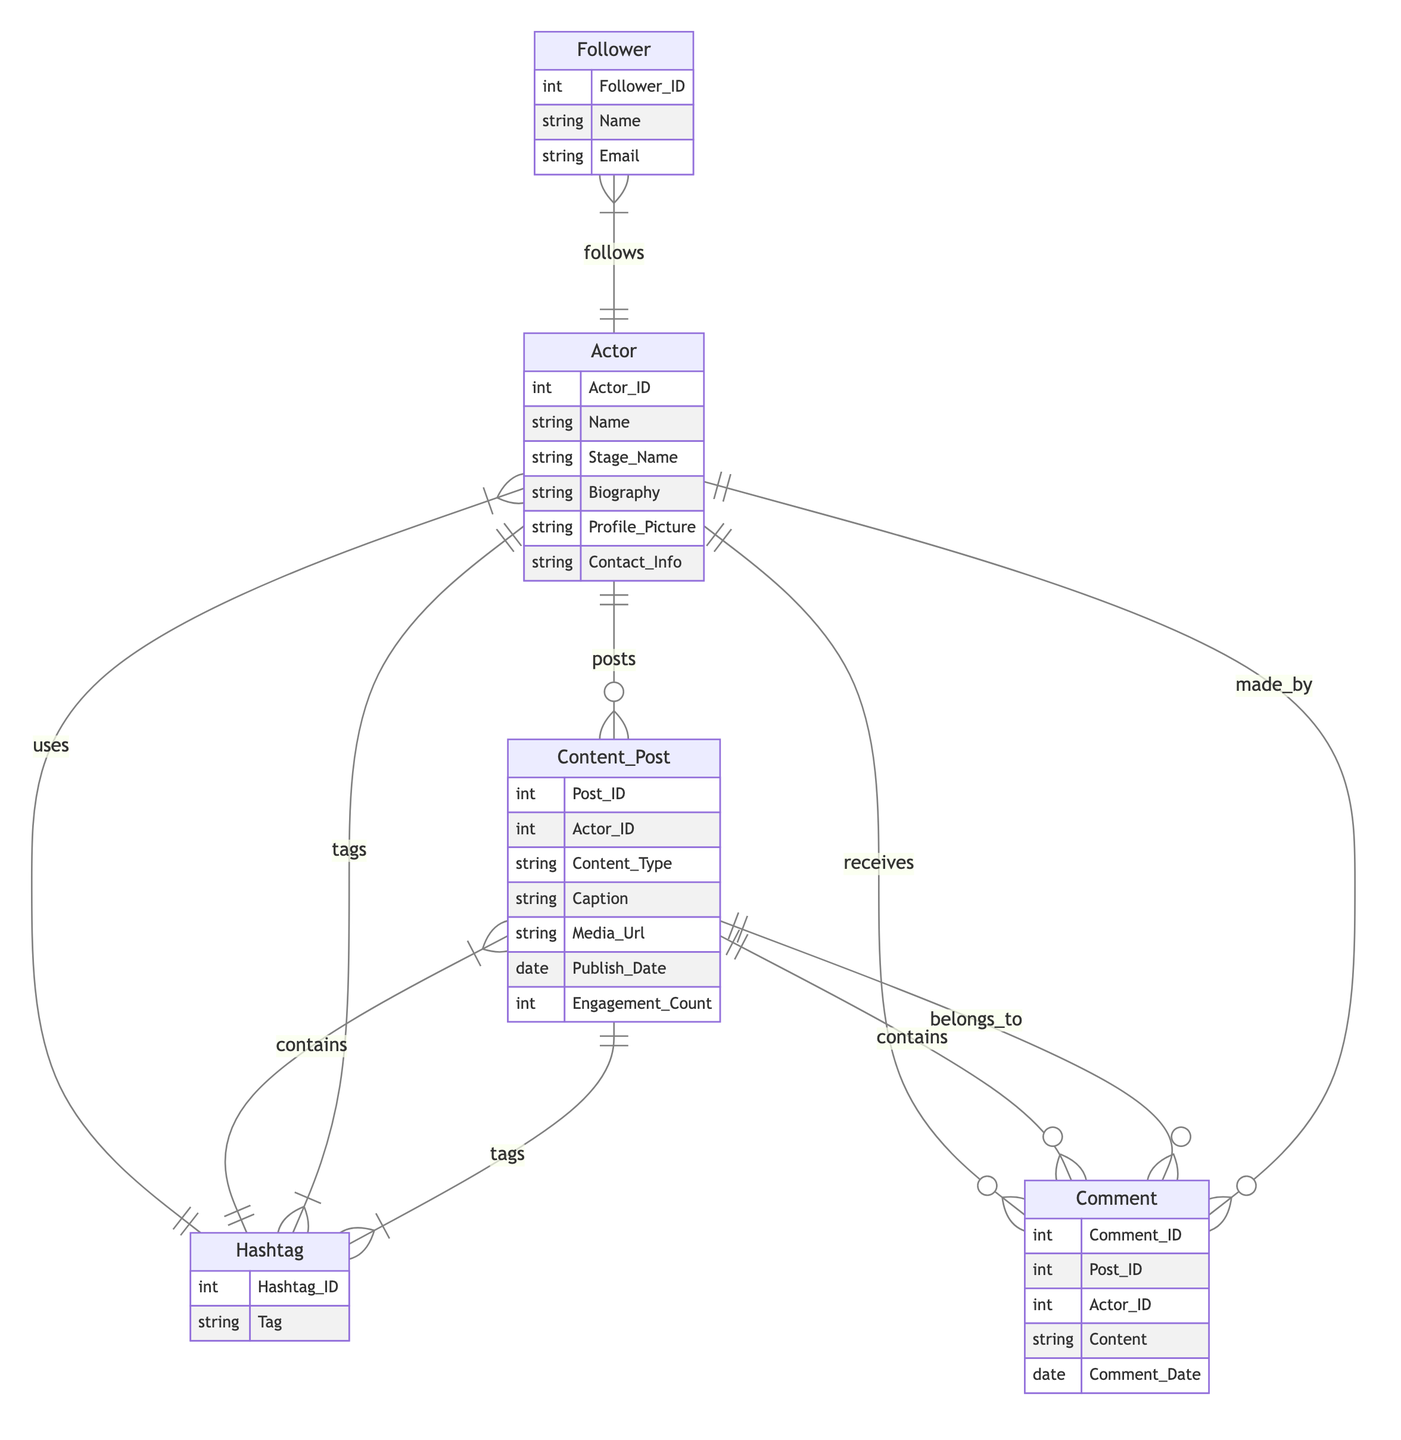What is the primary entity representing individuals who pursue acting? The diagram shows the "Actor" entity as the primary representation of individuals pursuing acting, as indicated by its distinct attributes and relationships.
Answer: Actor How many types of relationships does the Actor entity have? By examining the Actor entity, we see it has three relationships: posts, uses, and receives, indicating its interconnectedness with other entities.
Answer: Three Which entity is used to keep track of user comments on content posts? The relationship description shows that "Comment" is linked to "Content_Post" with the "contains" relationship, meaning it stores user responses on posts.
Answer: Comment How many hashtags can an Actor use? The relationship shows that an Actor can use many hashtags (many to many relationship), allowing each actor to engage with multiple tags throughout their social media presence.
Answer: Many What does the Content_Post entity contain? Content_Post contains attributes including Post_ID, Actor_ID, Content_Type, Caption, Media_Url, Publish_Date, and Engagement_Count, defining the data associated with each post made by actors.
Answer: Content_ID, Actor_ID, Content_Type, Caption, Media_Url, Publish_Date, Engagement_Count What type of relationship connects Followers and Actors? The relationship "follows" connects "Follower" and "Actor," indicating that followers can interact with or subscribe to actors they are interested in, demonstrating a many-to-many relationship.
Answer: Many to many How many comments can a Content_Post have? The "contains" relationship indicates that a Content_Post can have many comments associated with it, allowing for significant interaction and feedback.
Answer: Many What identifies each Comment within the Comment entity? Each Comment is uniquely identified by the Comment_ID attribute, which provides a distinct identifier for tracking individual comments made on posts.
Answer: Comment_ID How are hashtags associated with Content Posts? The relationship document indicates hashtags are linked to Content_Post through a many-to-many relationship, meaning multiple posts can feature many shared hashtags, assisting in broader audience engagement.
Answer: Many to Many 